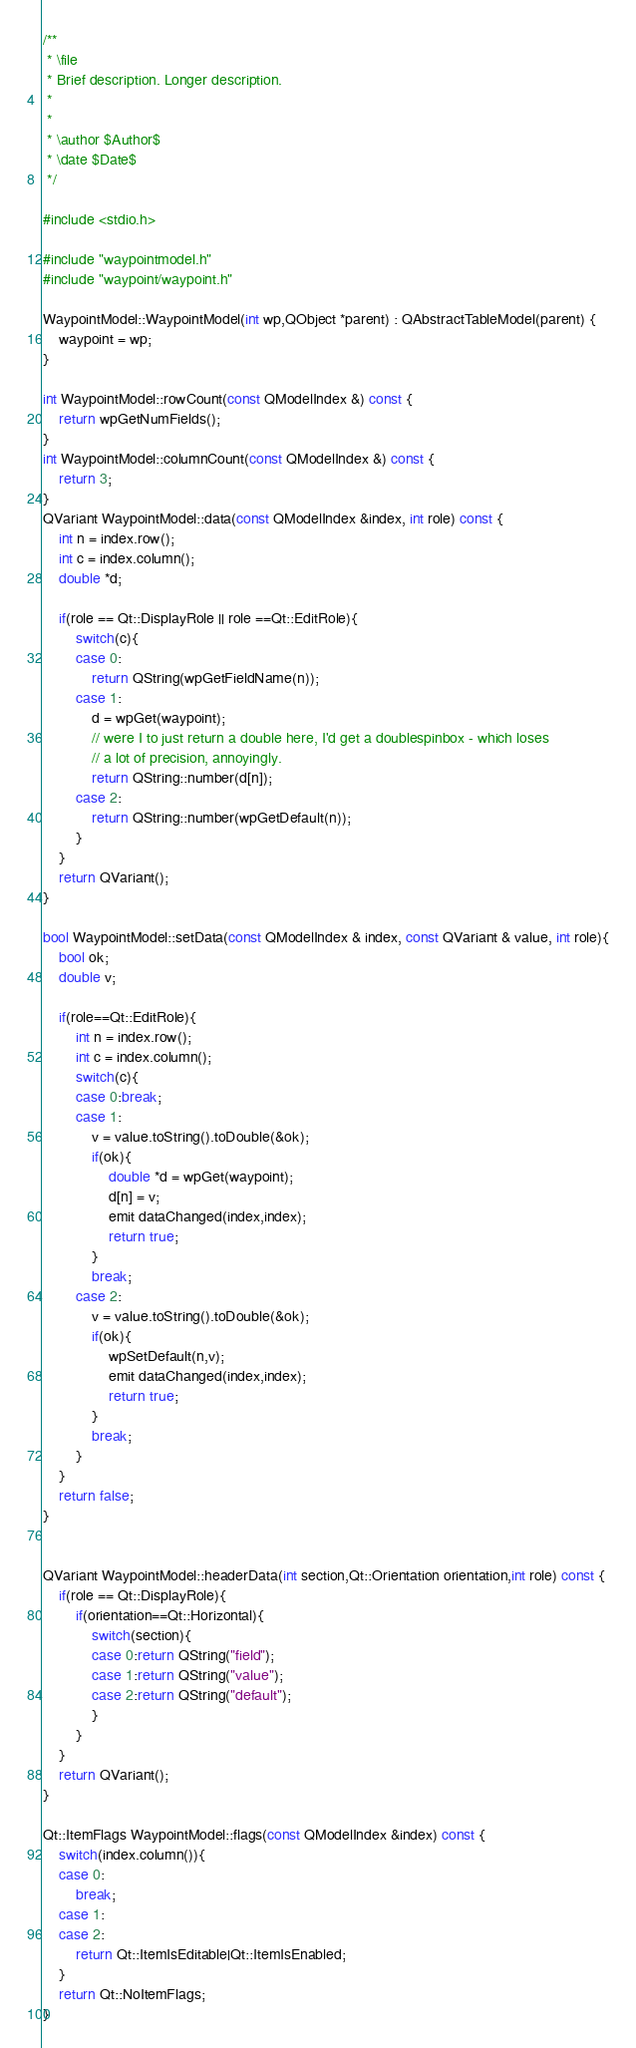Convert code to text. <code><loc_0><loc_0><loc_500><loc_500><_C++_>/**
 * \file
 * Brief description. Longer description.
 *
 * 
 * \author $Author$
 * \date $Date$
 */

#include <stdio.h>

#include "waypointmodel.h"
#include "waypoint/waypoint.h"

WaypointModel::WaypointModel(int wp,QObject *parent) : QAbstractTableModel(parent) {
    waypoint = wp;
}

int WaypointModel::rowCount(const QModelIndex &) const {
    return wpGetNumFields();
}
int WaypointModel::columnCount(const QModelIndex &) const {
    return 3;
}
QVariant WaypointModel::data(const QModelIndex &index, int role) const {
    int n = index.row();
    int c = index.column();
    double *d;
    
    if(role == Qt::DisplayRole || role ==Qt::EditRole){
        switch(c){
        case 0:
            return QString(wpGetFieldName(n));
        case 1:
            d = wpGet(waypoint);
            // were I to just return a double here, I'd get a doublespinbox - which loses
            // a lot of precision, annoyingly.
            return QString::number(d[n]);
        case 2:
            return QString::number(wpGetDefault(n));
        }
    }
    return QVariant();
}

bool WaypointModel::setData(const QModelIndex & index, const QVariant & value, int role){
    bool ok;
    double v;
    
    if(role==Qt::EditRole){
        int n = index.row();
        int c = index.column();
        switch(c){
        case 0:break;
        case 1:
            v = value.toString().toDouble(&ok);
            if(ok){
                double *d = wpGet(waypoint);
                d[n] = v;
                emit dataChanged(index,index);
                return true;
            }
            break;
        case 2:
            v = value.toString().toDouble(&ok);
            if(ok){
                wpSetDefault(n,v);
                emit dataChanged(index,index);
                return true;
            }
            break;
        }
    }
    return false;
}


QVariant WaypointModel::headerData(int section,Qt::Orientation orientation,int role) const {
    if(role == Qt::DisplayRole){
        if(orientation==Qt::Horizontal){
            switch(section){
            case 0:return QString("field");
            case 1:return QString("value");
            case 2:return QString("default");
            }
        }
    }
    return QVariant();
}

Qt::ItemFlags WaypointModel::flags(const QModelIndex &index) const {
    switch(index.column()){
    case 0:
        break;
    case 1:
    case 2:
        return Qt::ItemIsEditable|Qt::ItemIsEnabled;
    }
    return Qt::NoItemFlags;
}
</code> 